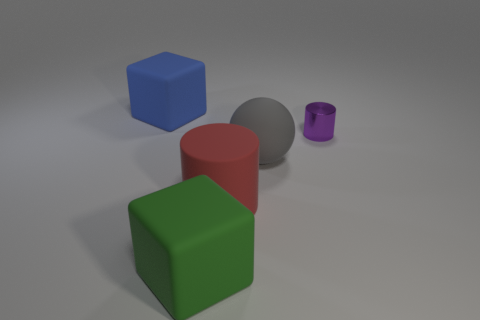What number of rubber objects are either blue cubes or cylinders?
Offer a terse response. 2. Are there any other things of the same color as the big cylinder?
Provide a short and direct response. No. Is the shape of the big red matte object that is in front of the big blue matte object the same as the thing to the right of the gray matte ball?
Your response must be concise. Yes. What number of things are large green matte objects or big red rubber things left of the rubber ball?
Ensure brevity in your answer.  2. What number of other objects are there of the same size as the green object?
Make the answer very short. 3. Is the material of the big block in front of the blue thing the same as the cylinder that is left of the tiny purple thing?
Keep it short and to the point. Yes. What number of big blue cubes are on the right side of the big blue cube?
Give a very brief answer. 0. How many red things are tiny metal cylinders or rubber cylinders?
Give a very brief answer. 1. What shape is the rubber thing that is behind the matte cylinder and left of the red matte cylinder?
Your answer should be compact. Cube. There is a cylinder that is the same size as the gray rubber thing; what color is it?
Your response must be concise. Red. 